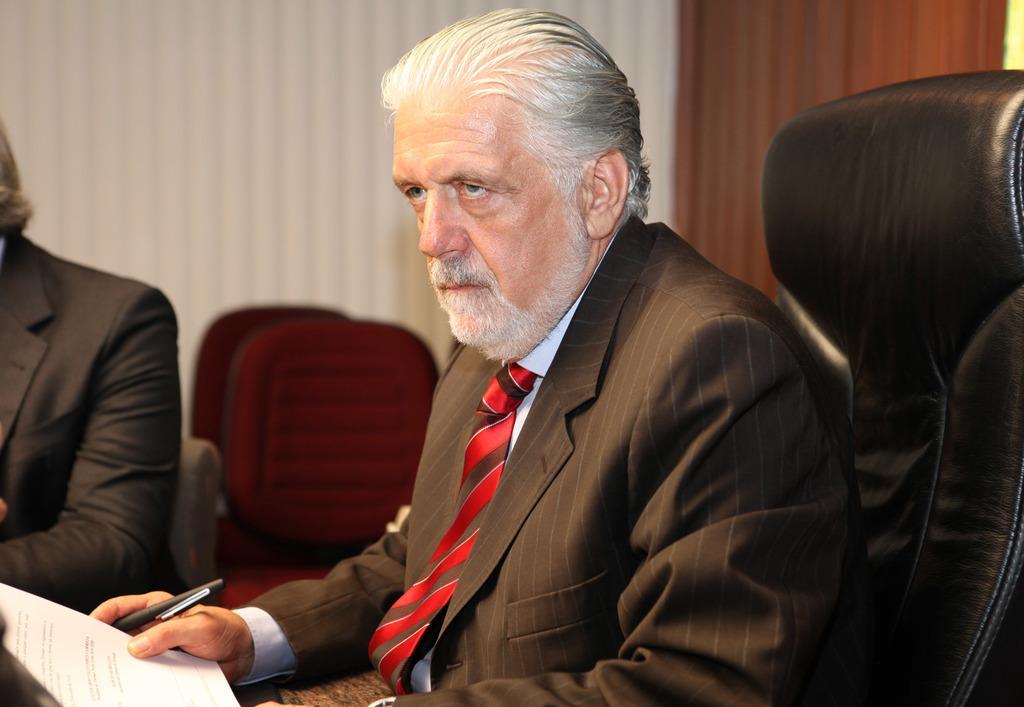Could you give a brief overview of what you see in this image? In this image I can see a two person siting on the chair and holding a paper and pen. 